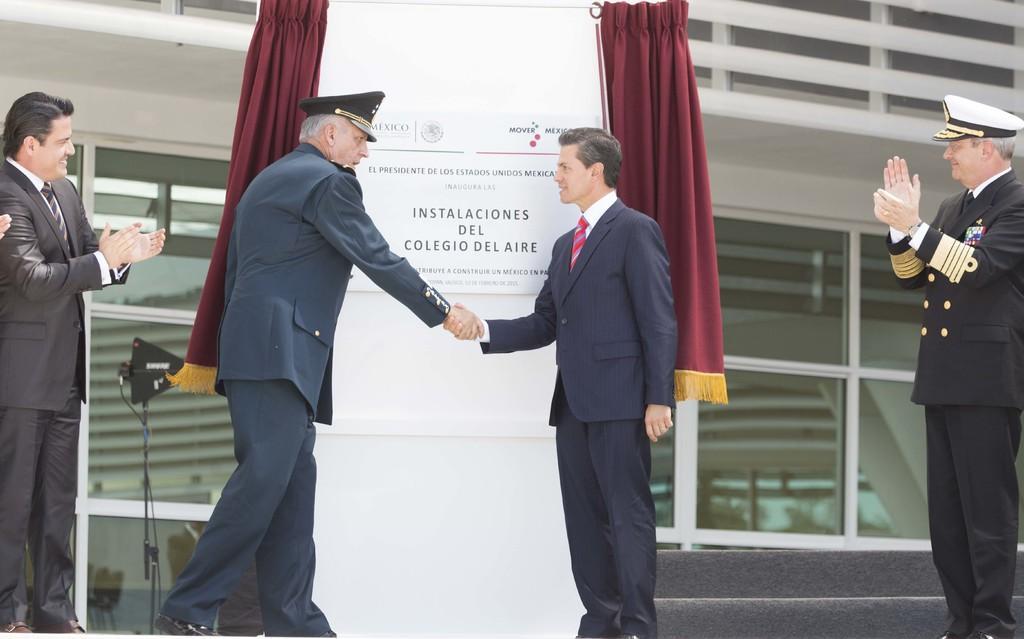Could you give a brief overview of what you see in this image? These two men shaking hands each other and these two men clapping their hands. We can see board on the white surface and curtains. In the background we can see stand,fence,wall and glass windows. 